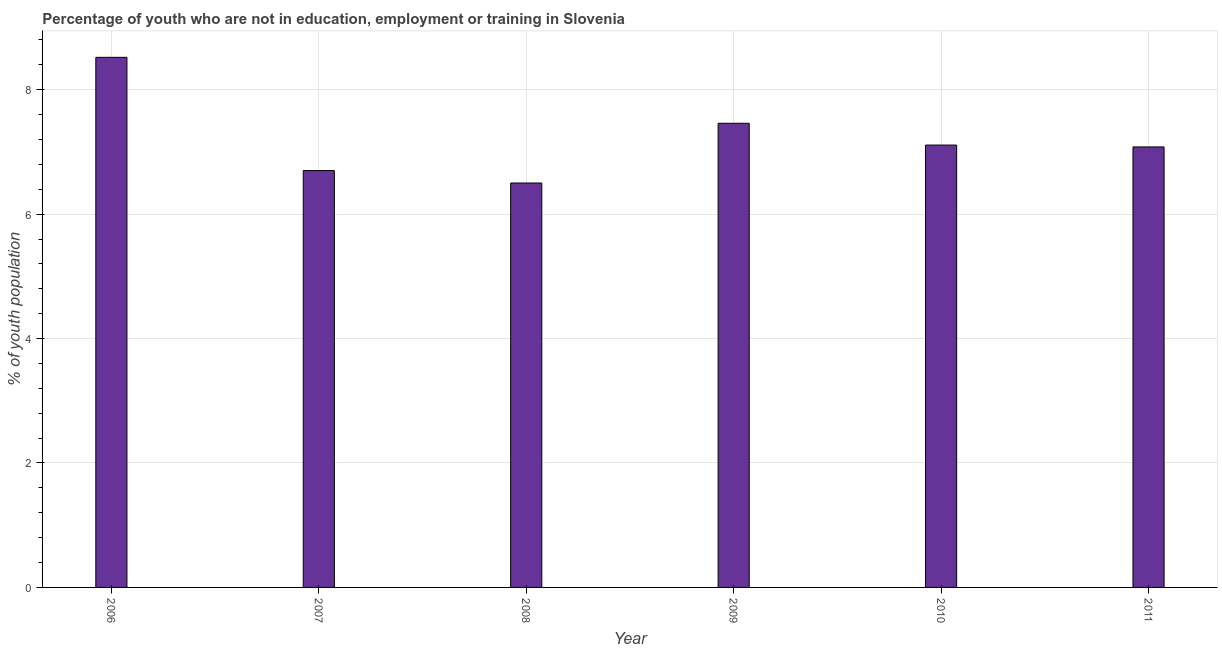What is the title of the graph?
Make the answer very short. Percentage of youth who are not in education, employment or training in Slovenia. What is the label or title of the X-axis?
Provide a succinct answer. Year. What is the label or title of the Y-axis?
Give a very brief answer. % of youth population. What is the unemployed youth population in 2009?
Ensure brevity in your answer.  7.46. Across all years, what is the maximum unemployed youth population?
Your answer should be very brief. 8.52. In which year was the unemployed youth population maximum?
Give a very brief answer. 2006. What is the sum of the unemployed youth population?
Your answer should be very brief. 43.37. What is the difference between the unemployed youth population in 2006 and 2007?
Your answer should be very brief. 1.82. What is the average unemployed youth population per year?
Your answer should be very brief. 7.23. What is the median unemployed youth population?
Offer a very short reply. 7.1. What is the ratio of the unemployed youth population in 2006 to that in 2011?
Your response must be concise. 1.2. What is the difference between the highest and the second highest unemployed youth population?
Provide a succinct answer. 1.06. Is the sum of the unemployed youth population in 2008 and 2011 greater than the maximum unemployed youth population across all years?
Ensure brevity in your answer.  Yes. What is the difference between the highest and the lowest unemployed youth population?
Your response must be concise. 2.02. Are all the bars in the graph horizontal?
Give a very brief answer. No. How many years are there in the graph?
Provide a succinct answer. 6. What is the difference between two consecutive major ticks on the Y-axis?
Ensure brevity in your answer.  2. Are the values on the major ticks of Y-axis written in scientific E-notation?
Offer a very short reply. No. What is the % of youth population of 2006?
Your answer should be very brief. 8.52. What is the % of youth population of 2007?
Your response must be concise. 6.7. What is the % of youth population of 2009?
Provide a succinct answer. 7.46. What is the % of youth population of 2010?
Give a very brief answer. 7.11. What is the % of youth population in 2011?
Provide a short and direct response. 7.08. What is the difference between the % of youth population in 2006 and 2007?
Make the answer very short. 1.82. What is the difference between the % of youth population in 2006 and 2008?
Provide a short and direct response. 2.02. What is the difference between the % of youth population in 2006 and 2009?
Ensure brevity in your answer.  1.06. What is the difference between the % of youth population in 2006 and 2010?
Make the answer very short. 1.41. What is the difference between the % of youth population in 2006 and 2011?
Keep it short and to the point. 1.44. What is the difference between the % of youth population in 2007 and 2009?
Your response must be concise. -0.76. What is the difference between the % of youth population in 2007 and 2010?
Provide a succinct answer. -0.41. What is the difference between the % of youth population in 2007 and 2011?
Make the answer very short. -0.38. What is the difference between the % of youth population in 2008 and 2009?
Your answer should be very brief. -0.96. What is the difference between the % of youth population in 2008 and 2010?
Keep it short and to the point. -0.61. What is the difference between the % of youth population in 2008 and 2011?
Keep it short and to the point. -0.58. What is the difference between the % of youth population in 2009 and 2010?
Make the answer very short. 0.35. What is the difference between the % of youth population in 2009 and 2011?
Your response must be concise. 0.38. What is the difference between the % of youth population in 2010 and 2011?
Offer a very short reply. 0.03. What is the ratio of the % of youth population in 2006 to that in 2007?
Keep it short and to the point. 1.27. What is the ratio of the % of youth population in 2006 to that in 2008?
Your answer should be very brief. 1.31. What is the ratio of the % of youth population in 2006 to that in 2009?
Ensure brevity in your answer.  1.14. What is the ratio of the % of youth population in 2006 to that in 2010?
Ensure brevity in your answer.  1.2. What is the ratio of the % of youth population in 2006 to that in 2011?
Make the answer very short. 1.2. What is the ratio of the % of youth population in 2007 to that in 2008?
Your response must be concise. 1.03. What is the ratio of the % of youth population in 2007 to that in 2009?
Offer a terse response. 0.9. What is the ratio of the % of youth population in 2007 to that in 2010?
Ensure brevity in your answer.  0.94. What is the ratio of the % of youth population in 2007 to that in 2011?
Offer a very short reply. 0.95. What is the ratio of the % of youth population in 2008 to that in 2009?
Give a very brief answer. 0.87. What is the ratio of the % of youth population in 2008 to that in 2010?
Keep it short and to the point. 0.91. What is the ratio of the % of youth population in 2008 to that in 2011?
Your answer should be very brief. 0.92. What is the ratio of the % of youth population in 2009 to that in 2010?
Provide a succinct answer. 1.05. What is the ratio of the % of youth population in 2009 to that in 2011?
Offer a very short reply. 1.05. What is the ratio of the % of youth population in 2010 to that in 2011?
Make the answer very short. 1. 